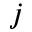Convert formula to latex. <formula><loc_0><loc_0><loc_500><loc_500>j</formula> 